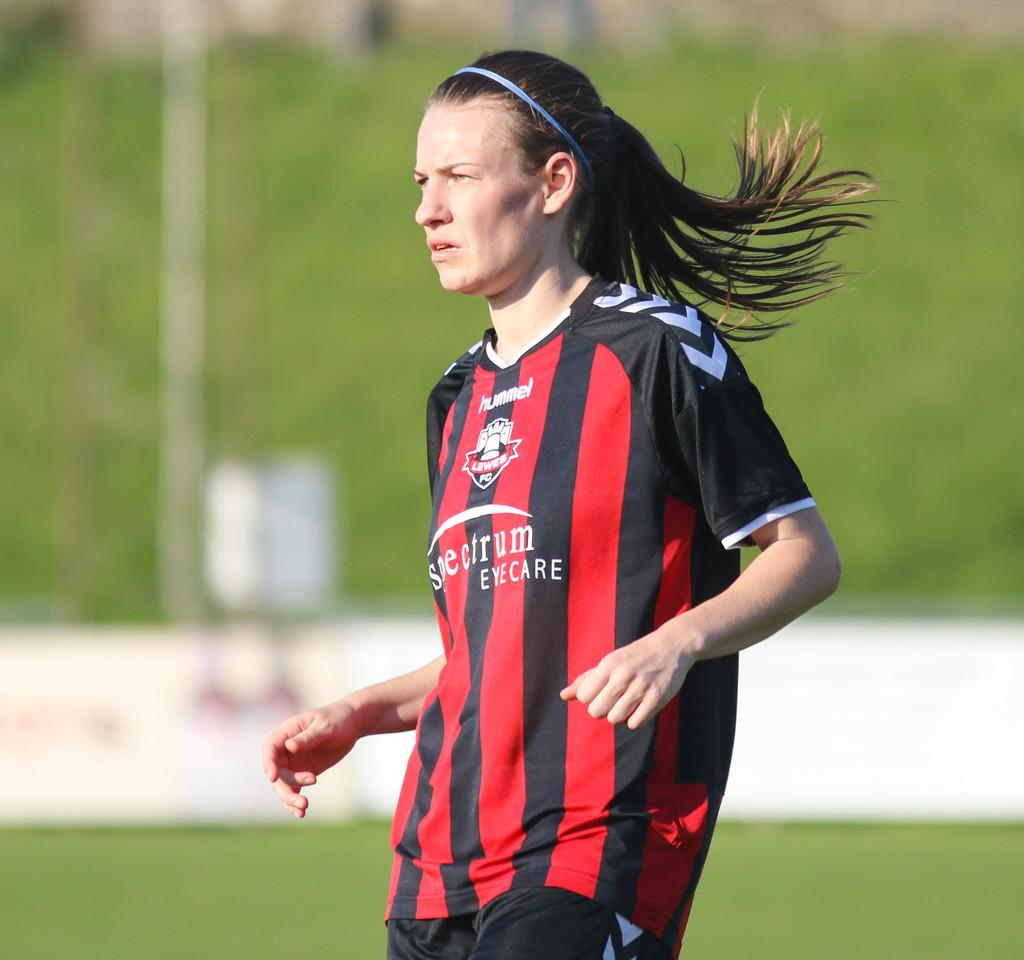<image>
Create a compact narrative representing the image presented. A woman is on a green field in a red and black, striped shirt that says Spectrum Eyecare, just below Hummel Lewes. 